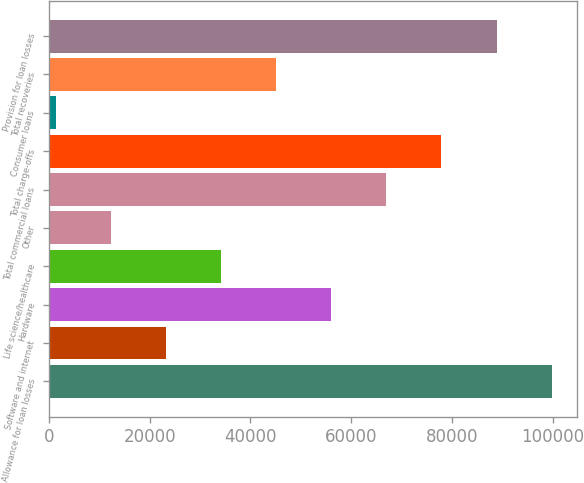<chart> <loc_0><loc_0><loc_500><loc_500><bar_chart><fcel>Allowance for loan losses<fcel>Software and internet<fcel>Hardware<fcel>Life science/healthcare<fcel>Other<fcel>Total commercial loans<fcel>Total charge-offs<fcel>Consumer loans<fcel>Total recoveries<fcel>Provision for loan losses<nl><fcel>99721<fcel>23211<fcel>56001<fcel>34141<fcel>12281<fcel>66931<fcel>77861<fcel>1351<fcel>45071<fcel>88791<nl></chart> 